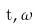<formula> <loc_0><loc_0><loc_500><loc_500>\hat { t } , \hat { \omega }</formula> 